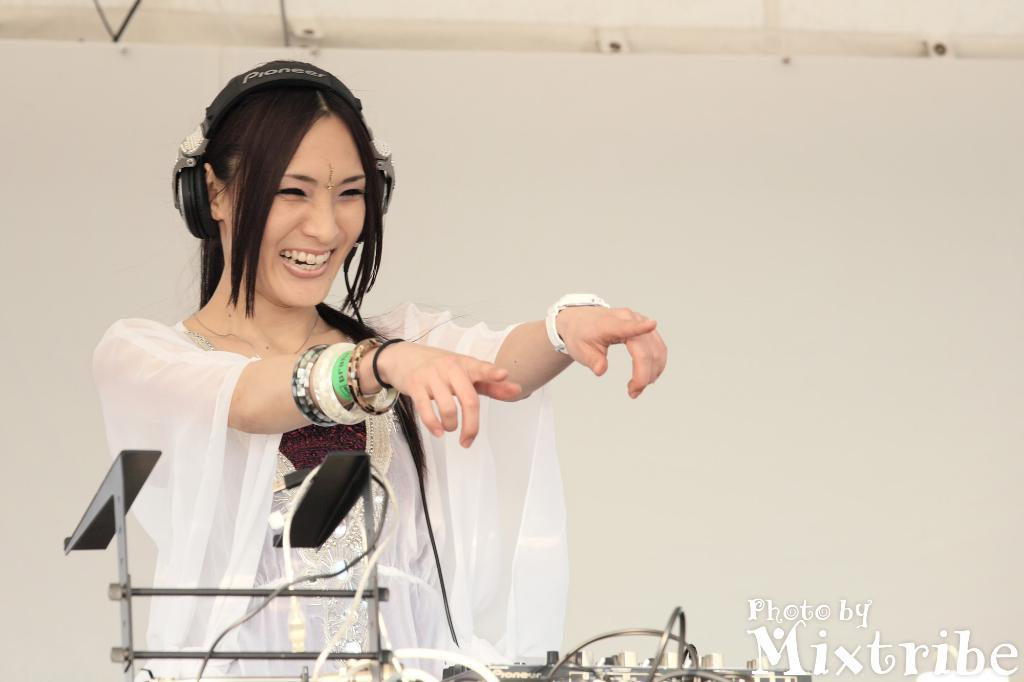Who is present in the image? There is a woman in the image. What is the woman wearing? The woman is wearing a white dress. What can be seen in front of the woman? There is an ash-colored object in front of the woman. What is the color of the background in the image? The background of the image is white. What type of can does the woman use to store dinosaur fossils in the image? There is no can or dinosaur fossils present in the image. 